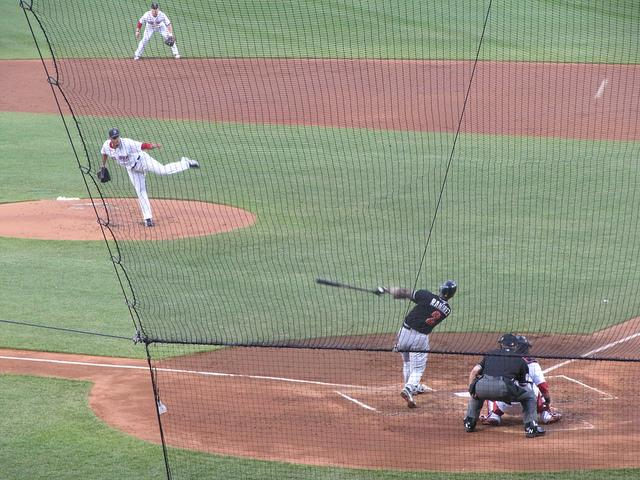What is the position of the player in the middle of the field? pitcher 